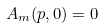Convert formula to latex. <formula><loc_0><loc_0><loc_500><loc_500>A _ { m } ( p , 0 ) = 0</formula> 